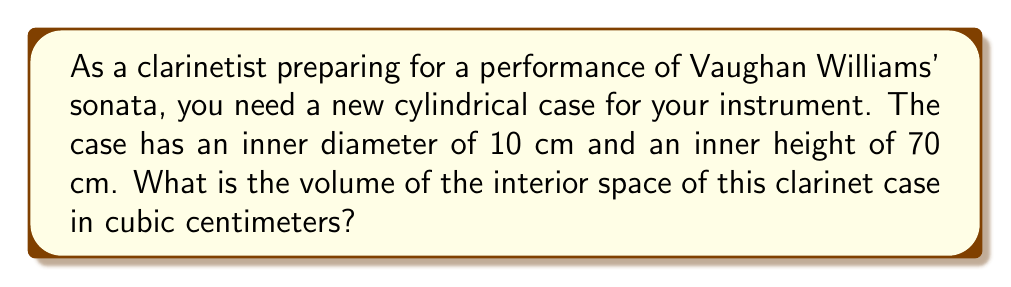Solve this math problem. To find the volume of the cylindrical clarinet case, we need to use the formula for the volume of a cylinder:

$$V = \pi r^2 h$$

Where:
$V$ = volume
$r$ = radius of the base
$h$ = height of the cylinder

Let's break it down step-by-step:

1. We're given the diameter of 10 cm. To find the radius, we divide this by 2:
   $r = 10 \text{ cm} \div 2 = 5 \text{ cm}$

2. The height is given as 70 cm.

3. Now, let's substitute these values into our formula:
   $$V = \pi (5 \text{ cm})^2 (70 \text{ cm})$$

4. Simplify the squared term:
   $$V = \pi (25 \text{ cm}^2) (70 \text{ cm})$$

5. Multiply the numbers:
   $$V = \pi (1750 \text{ cm}^3)$$

6. Calculate the final result:
   $$V \approx 5497.79 \text{ cm}^3$$

7. Rounding to the nearest cubic centimeter:
   $$V \approx 5498 \text{ cm}^3$$
Answer: $5498 \text{ cm}^3$ 